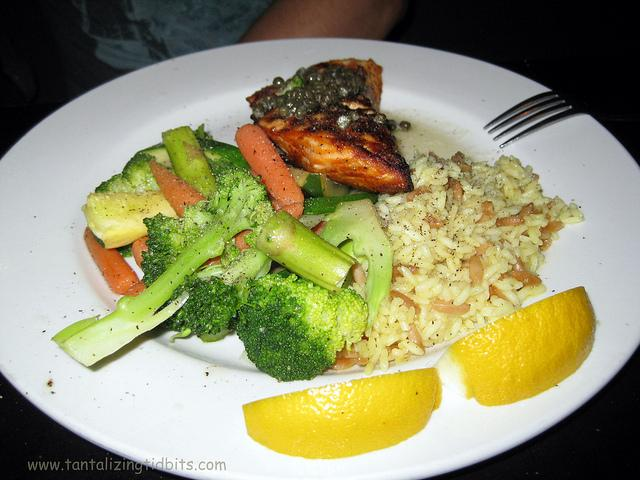What type of dish is this? Please explain your reasoning. entree. A plate of rice and vegetables is prepared and garnished with lemon wedges. 